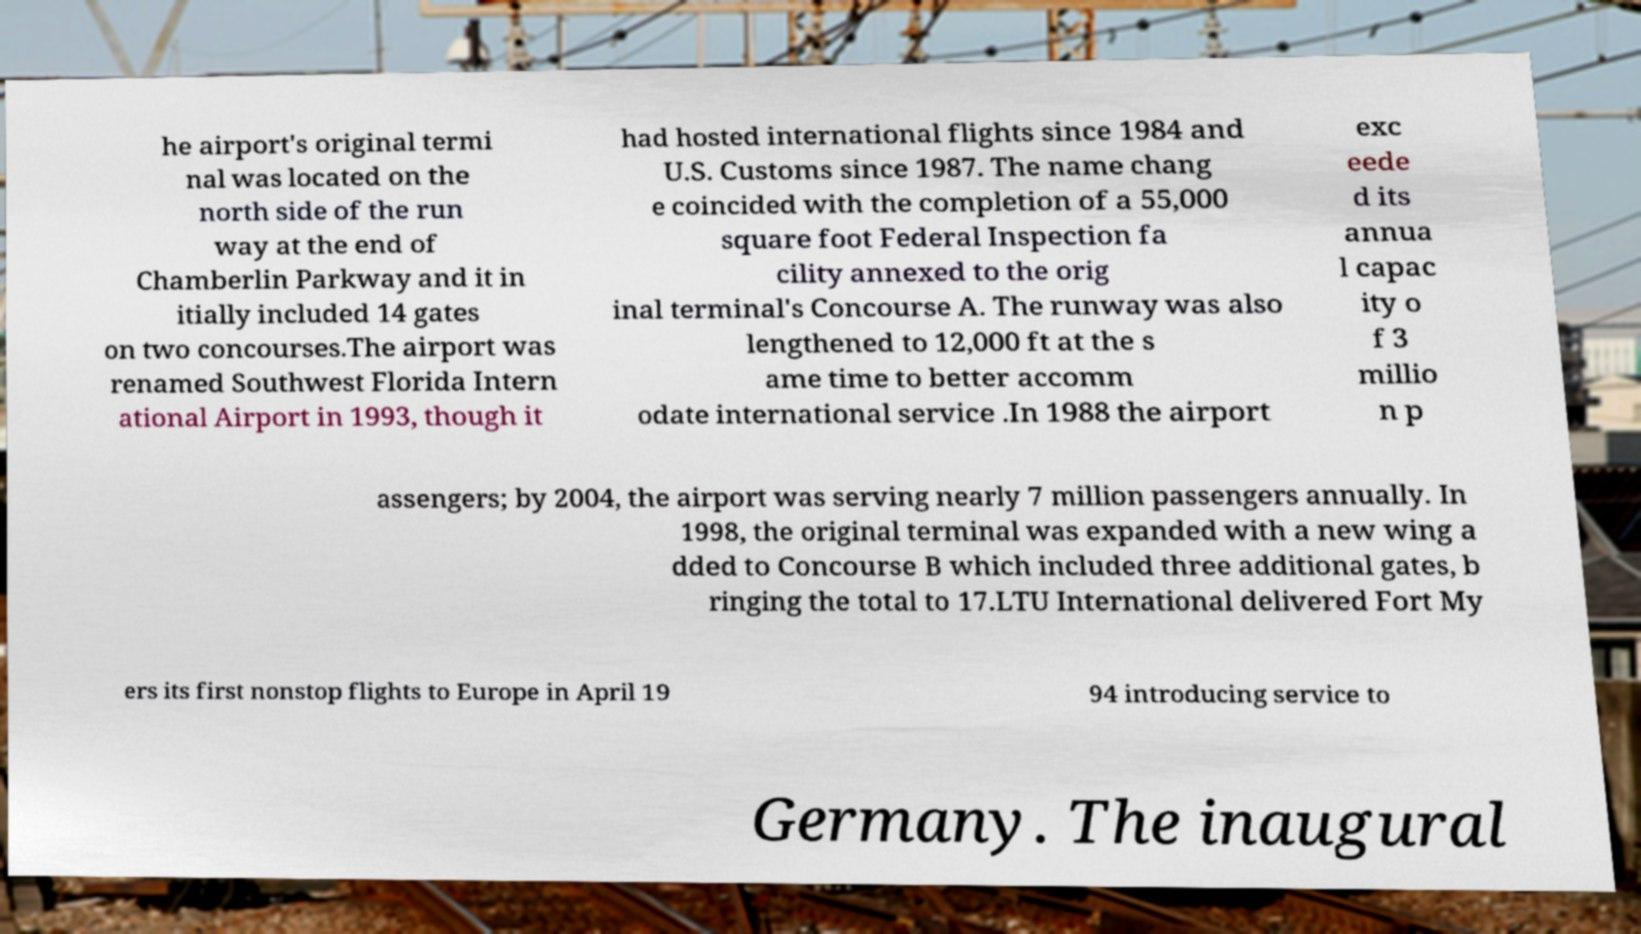Can you accurately transcribe the text from the provided image for me? he airport's original termi nal was located on the north side of the run way at the end of Chamberlin Parkway and it in itially included 14 gates on two concourses.The airport was renamed Southwest Florida Intern ational Airport in 1993, though it had hosted international flights since 1984 and U.S. Customs since 1987. The name chang e coincided with the completion of a 55,000 square foot Federal Inspection fa cility annexed to the orig inal terminal's Concourse A. The runway was also lengthened to 12,000 ft at the s ame time to better accomm odate international service .In 1988 the airport exc eede d its annua l capac ity o f 3 millio n p assengers; by 2004, the airport was serving nearly 7 million passengers annually. In 1998, the original terminal was expanded with a new wing a dded to Concourse B which included three additional gates, b ringing the total to 17.LTU International delivered Fort My ers its first nonstop flights to Europe in April 19 94 introducing service to Germany. The inaugural 